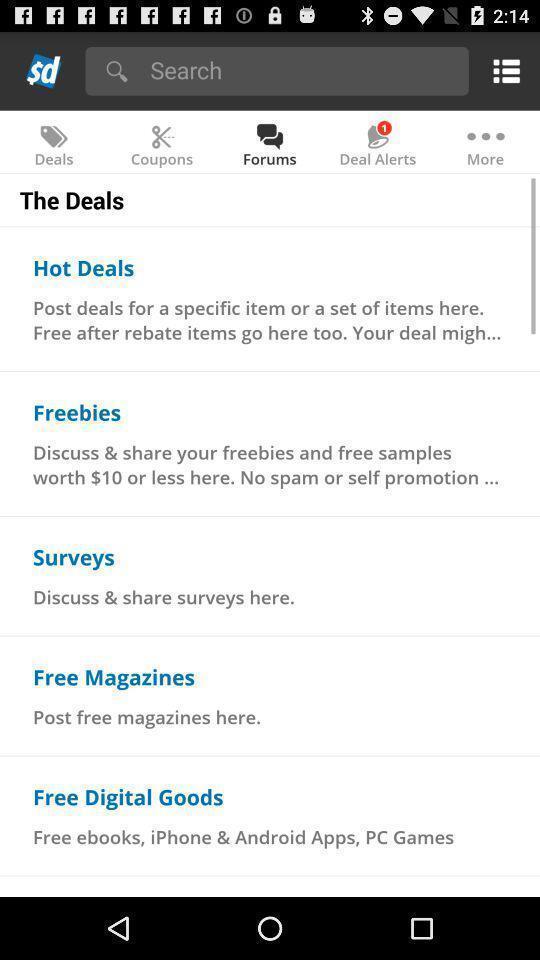Give me a summary of this screen capture. Screen shows multiple options in a shopping application. 